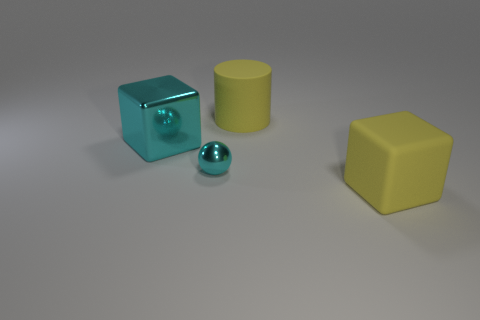Does the cylinder have the same color as the rubber cube?
Your answer should be compact. Yes. What is the material of the small cyan thing?
Keep it short and to the point. Metal. Are there an equal number of small cyan metallic things that are right of the large cyan cube and big blue matte cylinders?
Give a very brief answer. No. What is the shape of the yellow thing that is the same size as the matte cylinder?
Your answer should be very brief. Cube. There is a yellow thing that is behind the large cyan metallic block; are there any large yellow objects that are to the left of it?
Keep it short and to the point. No. How many large things are either spheres or purple cylinders?
Offer a terse response. 0. Is there a matte object that has the same size as the rubber block?
Make the answer very short. Yes. How many shiny objects are yellow blocks or tiny brown things?
Your answer should be very brief. 0. What shape is the metallic thing that is the same color as the tiny metal sphere?
Keep it short and to the point. Cube. What number of small yellow objects are there?
Provide a succinct answer. 0. 